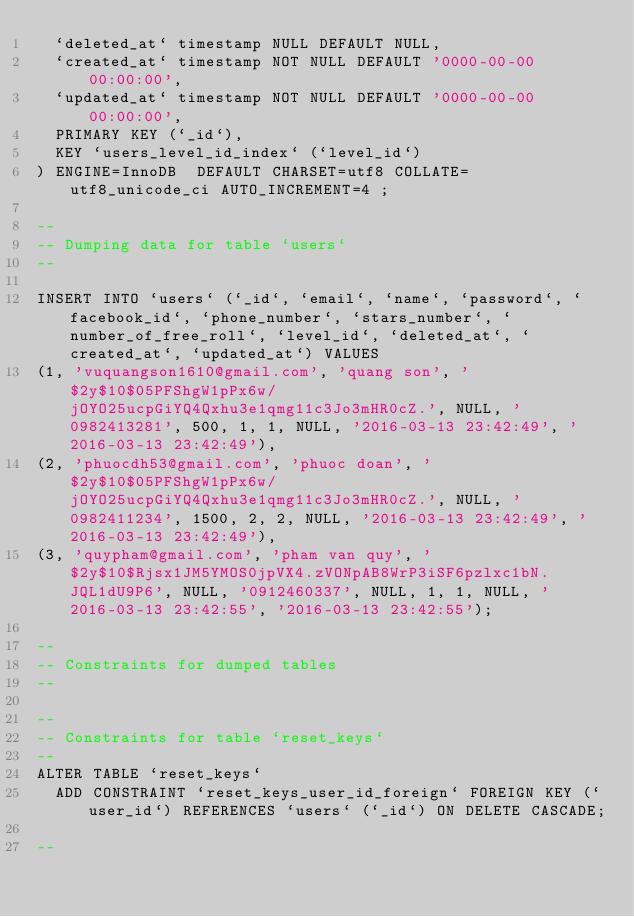Convert code to text. <code><loc_0><loc_0><loc_500><loc_500><_SQL_>  `deleted_at` timestamp NULL DEFAULT NULL,
  `created_at` timestamp NOT NULL DEFAULT '0000-00-00 00:00:00',
  `updated_at` timestamp NOT NULL DEFAULT '0000-00-00 00:00:00',
  PRIMARY KEY (`_id`),
  KEY `users_level_id_index` (`level_id`)
) ENGINE=InnoDB  DEFAULT CHARSET=utf8 COLLATE=utf8_unicode_ci AUTO_INCREMENT=4 ;

--
-- Dumping data for table `users`
--

INSERT INTO `users` (`_id`, `email`, `name`, `password`, `facebook_id`, `phone_number`, `stars_number`, `number_of_free_roll`, `level_id`, `deleted_at`, `created_at`, `updated_at`) VALUES
(1, 'vuquangson1610@gmail.com', 'quang son', '$2y$10$05PFShgW1pPx6w/jOYO25ucpGiYQ4Qxhu3e1qmg11c3Jo3mHR0cZ.', NULL, '0982413281', 500, 1, 1, NULL, '2016-03-13 23:42:49', '2016-03-13 23:42:49'),
(2, 'phuocdh53@gmail.com', 'phuoc doan', '$2y$10$05PFShgW1pPx6w/jOYO25ucpGiYQ4Qxhu3e1qmg11c3Jo3mHR0cZ.', NULL, '0982411234', 1500, 2, 2, NULL, '2016-03-13 23:42:49', '2016-03-13 23:42:49'),
(3, 'quypham@gmail.com', 'pham van quy', '$2y$10$Rjsx1JM5YMOS0jpVX4.zVONpAB8WrP3iSF6pzlxc1bN.JQL1dU9P6', NULL, '0912460337', NULL, 1, 1, NULL, '2016-03-13 23:42:55', '2016-03-13 23:42:55');

--
-- Constraints for dumped tables
--

--
-- Constraints for table `reset_keys`
--
ALTER TABLE `reset_keys`
  ADD CONSTRAINT `reset_keys_user_id_foreign` FOREIGN KEY (`user_id`) REFERENCES `users` (`_id`) ON DELETE CASCADE;

--</code> 